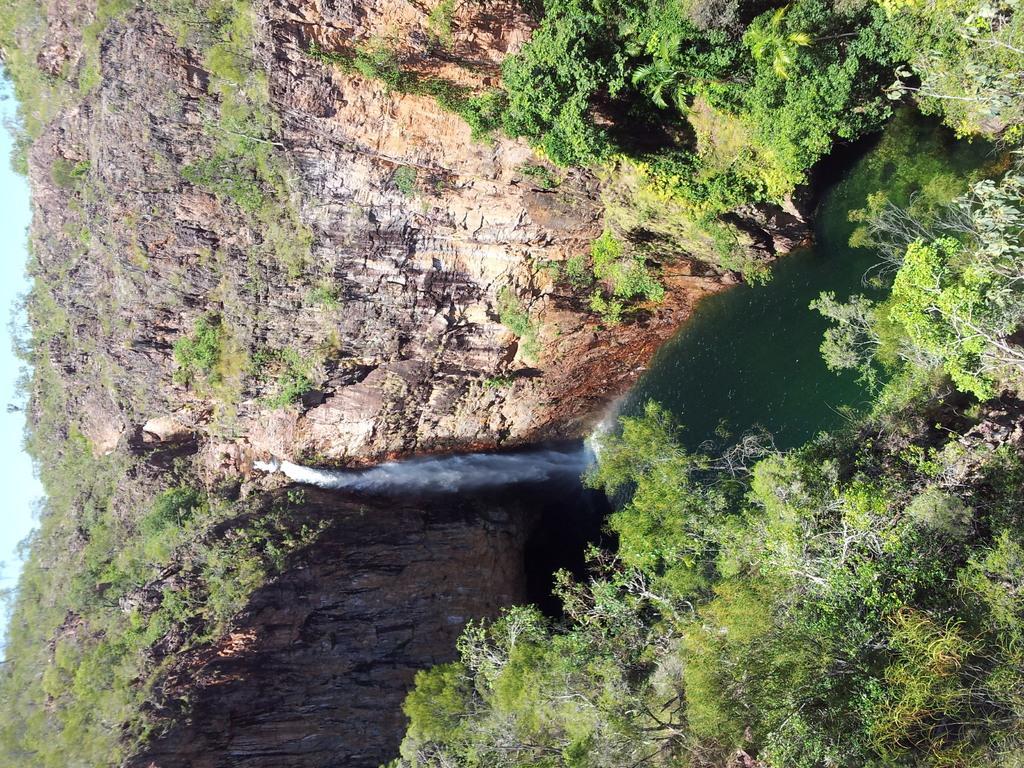Describe this image in one or two sentences. In this image I can see few trees which are green in color, the water, a mountain and water falling from the mountain. In the background I can see the sky. 